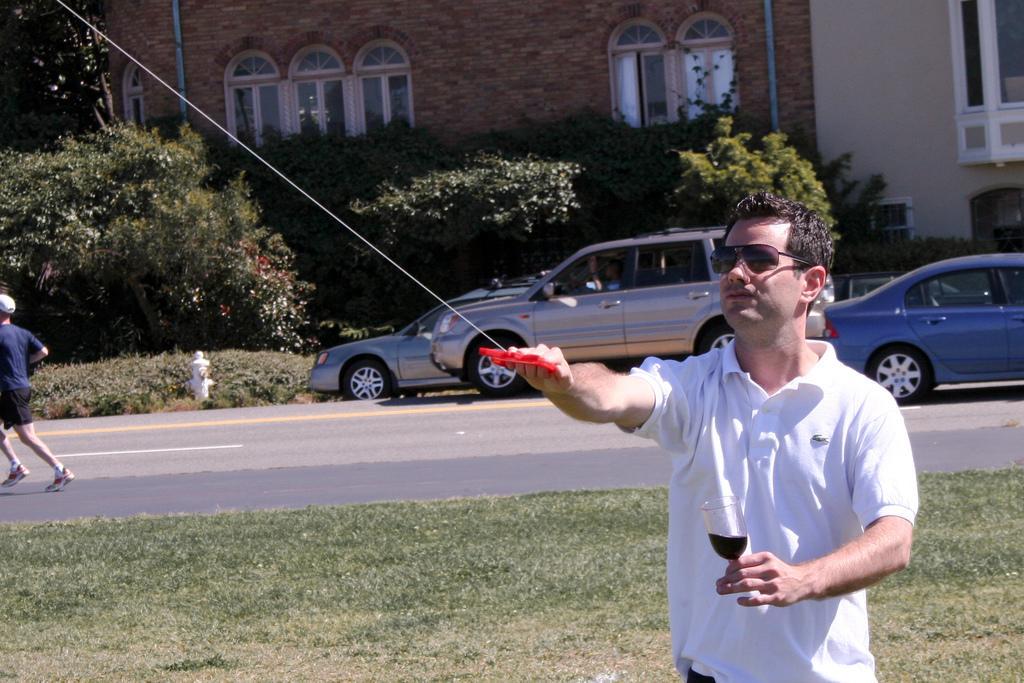Please provide a concise description of this image. This man wore goggles and holding a glass. Vehicles on road. This man is running as there is a leg movement. Far there is a building with window and plants. 